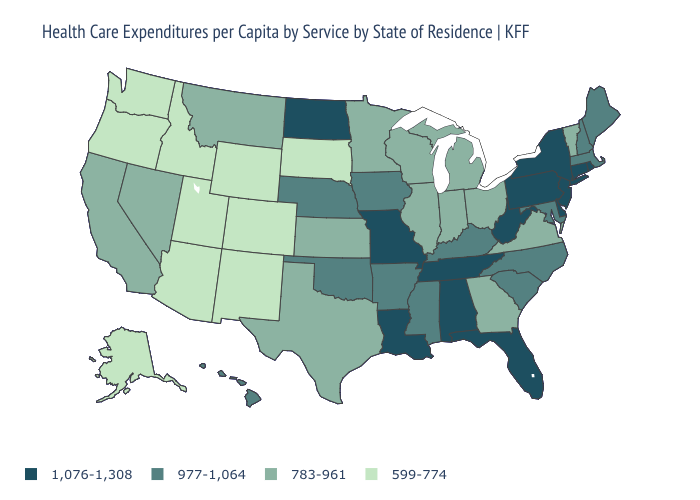Name the states that have a value in the range 977-1,064?
Quick response, please. Arkansas, Hawaii, Iowa, Kentucky, Maine, Maryland, Massachusetts, Mississippi, Nebraska, New Hampshire, North Carolina, Oklahoma, South Carolina. Name the states that have a value in the range 977-1,064?
Be succinct. Arkansas, Hawaii, Iowa, Kentucky, Maine, Maryland, Massachusetts, Mississippi, Nebraska, New Hampshire, North Carolina, Oklahoma, South Carolina. Among the states that border New York , does Vermont have the lowest value?
Answer briefly. Yes. Name the states that have a value in the range 599-774?
Concise answer only. Alaska, Arizona, Colorado, Idaho, New Mexico, Oregon, South Dakota, Utah, Washington, Wyoming. What is the value of Wyoming?
Answer briefly. 599-774. What is the value of Tennessee?
Short answer required. 1,076-1,308. What is the highest value in the USA?
Quick response, please. 1,076-1,308. Does Kansas have the highest value in the USA?
Keep it brief. No. What is the lowest value in the USA?
Concise answer only. 599-774. Among the states that border Mississippi , does Tennessee have the highest value?
Be succinct. Yes. Name the states that have a value in the range 977-1,064?
Give a very brief answer. Arkansas, Hawaii, Iowa, Kentucky, Maine, Maryland, Massachusetts, Mississippi, Nebraska, New Hampshire, North Carolina, Oklahoma, South Carolina. Name the states that have a value in the range 1,076-1,308?
Quick response, please. Alabama, Connecticut, Delaware, Florida, Louisiana, Missouri, New Jersey, New York, North Dakota, Pennsylvania, Rhode Island, Tennessee, West Virginia. Among the states that border Kentucky , does Ohio have the lowest value?
Short answer required. Yes. What is the lowest value in the MidWest?
Concise answer only. 599-774. What is the value of Kentucky?
Short answer required. 977-1,064. 